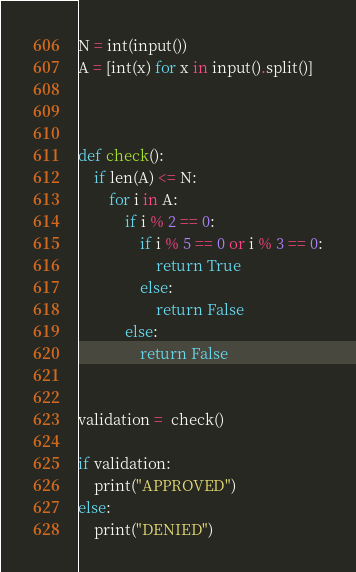Convert code to text. <code><loc_0><loc_0><loc_500><loc_500><_Python_>N = int(input())
A = [int(x) for x in input().split()]



def check():
    if len(A) <= N:
        for i in A:
            if i % 2 == 0:
                if i % 5 == 0 or i % 3 == 0:
                    return True
                else:
                    return False
            else:
                return False
                
                
validation =  check()

if validation:
    print("APPROVED")    
else:
    print("DENIED") 
</code> 